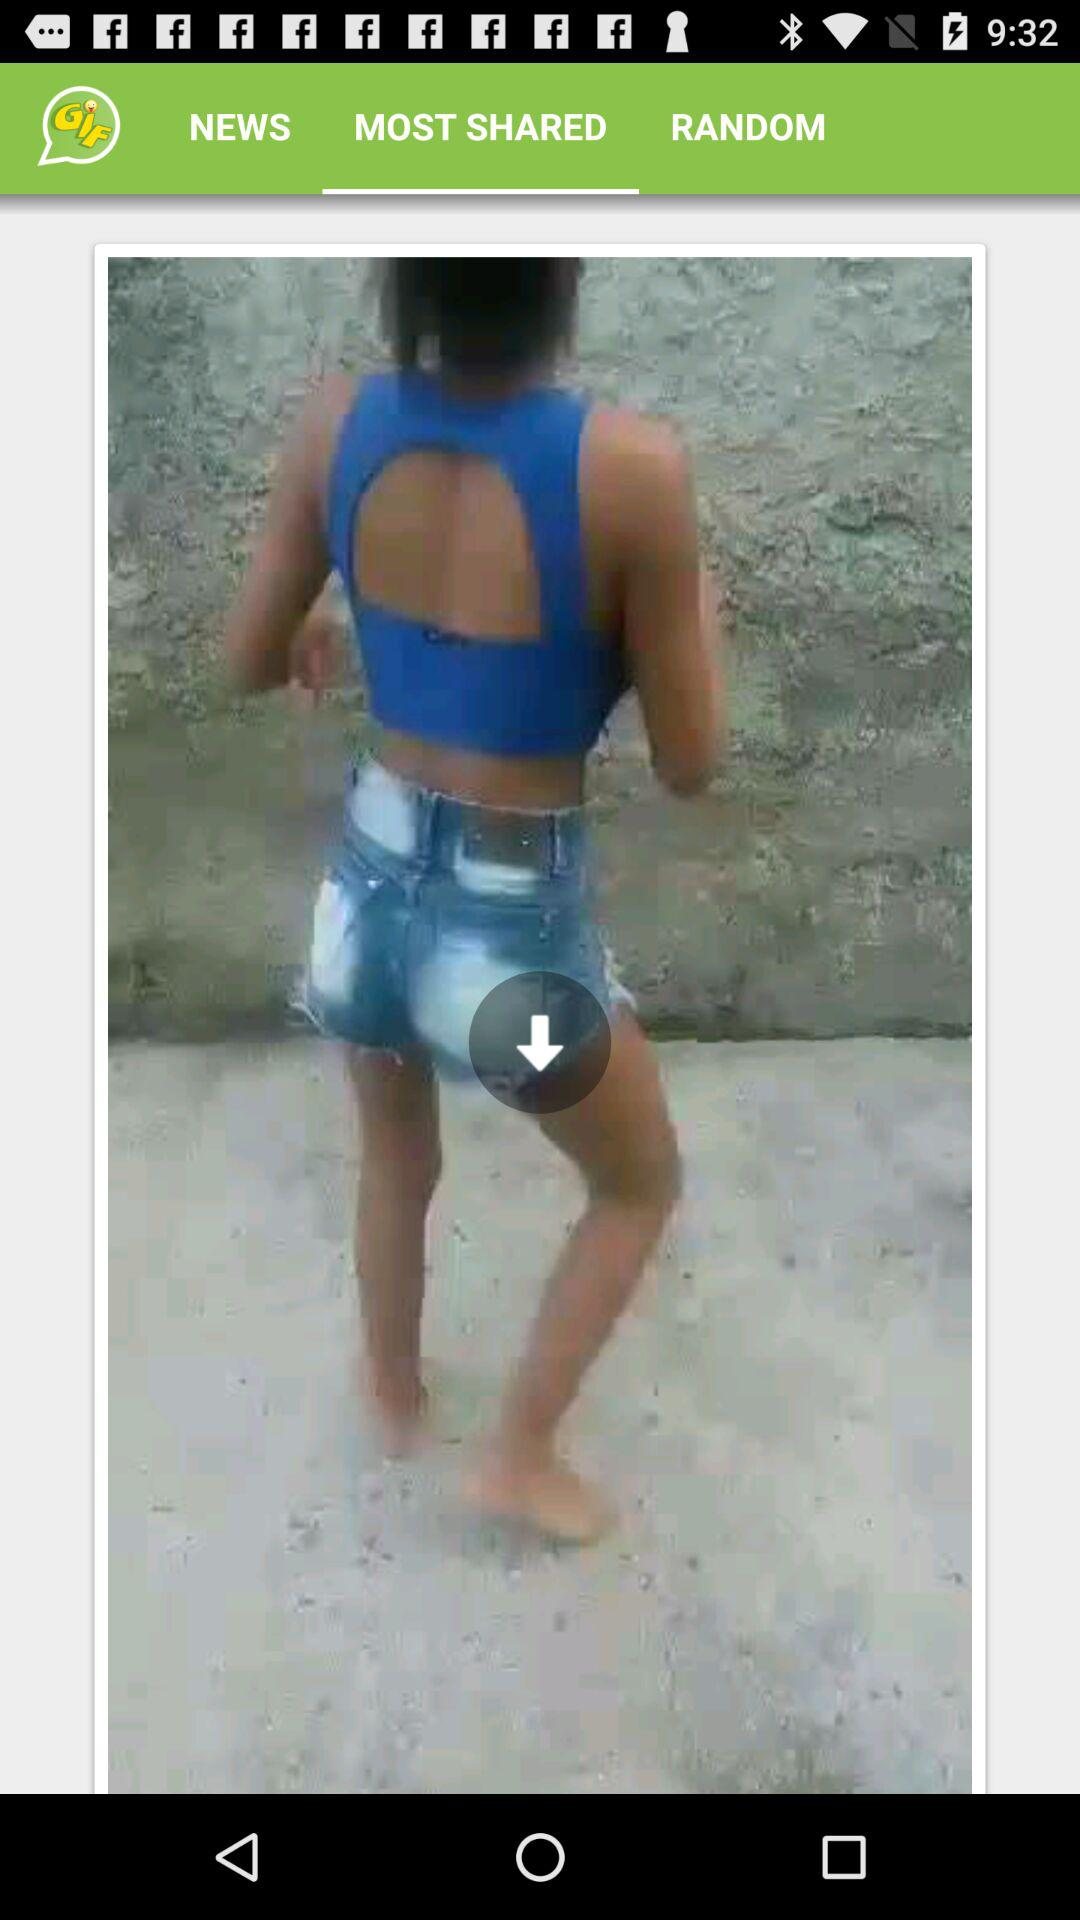Which tab am I on? You are on the "MOST SHARED" tab. 